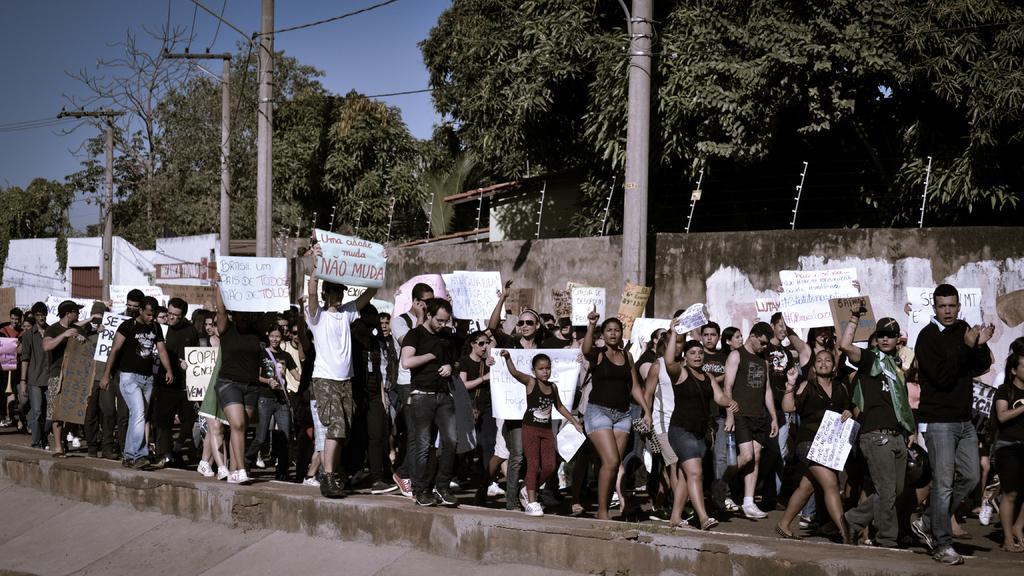Please provide a concise description of this image. In the foreground of the picture we can see people holding placards may be they are doing a protest. In the middle of the picture there are trees, poles, cables, wall and other objects. At the top there is sky. At the bottom it is road. 